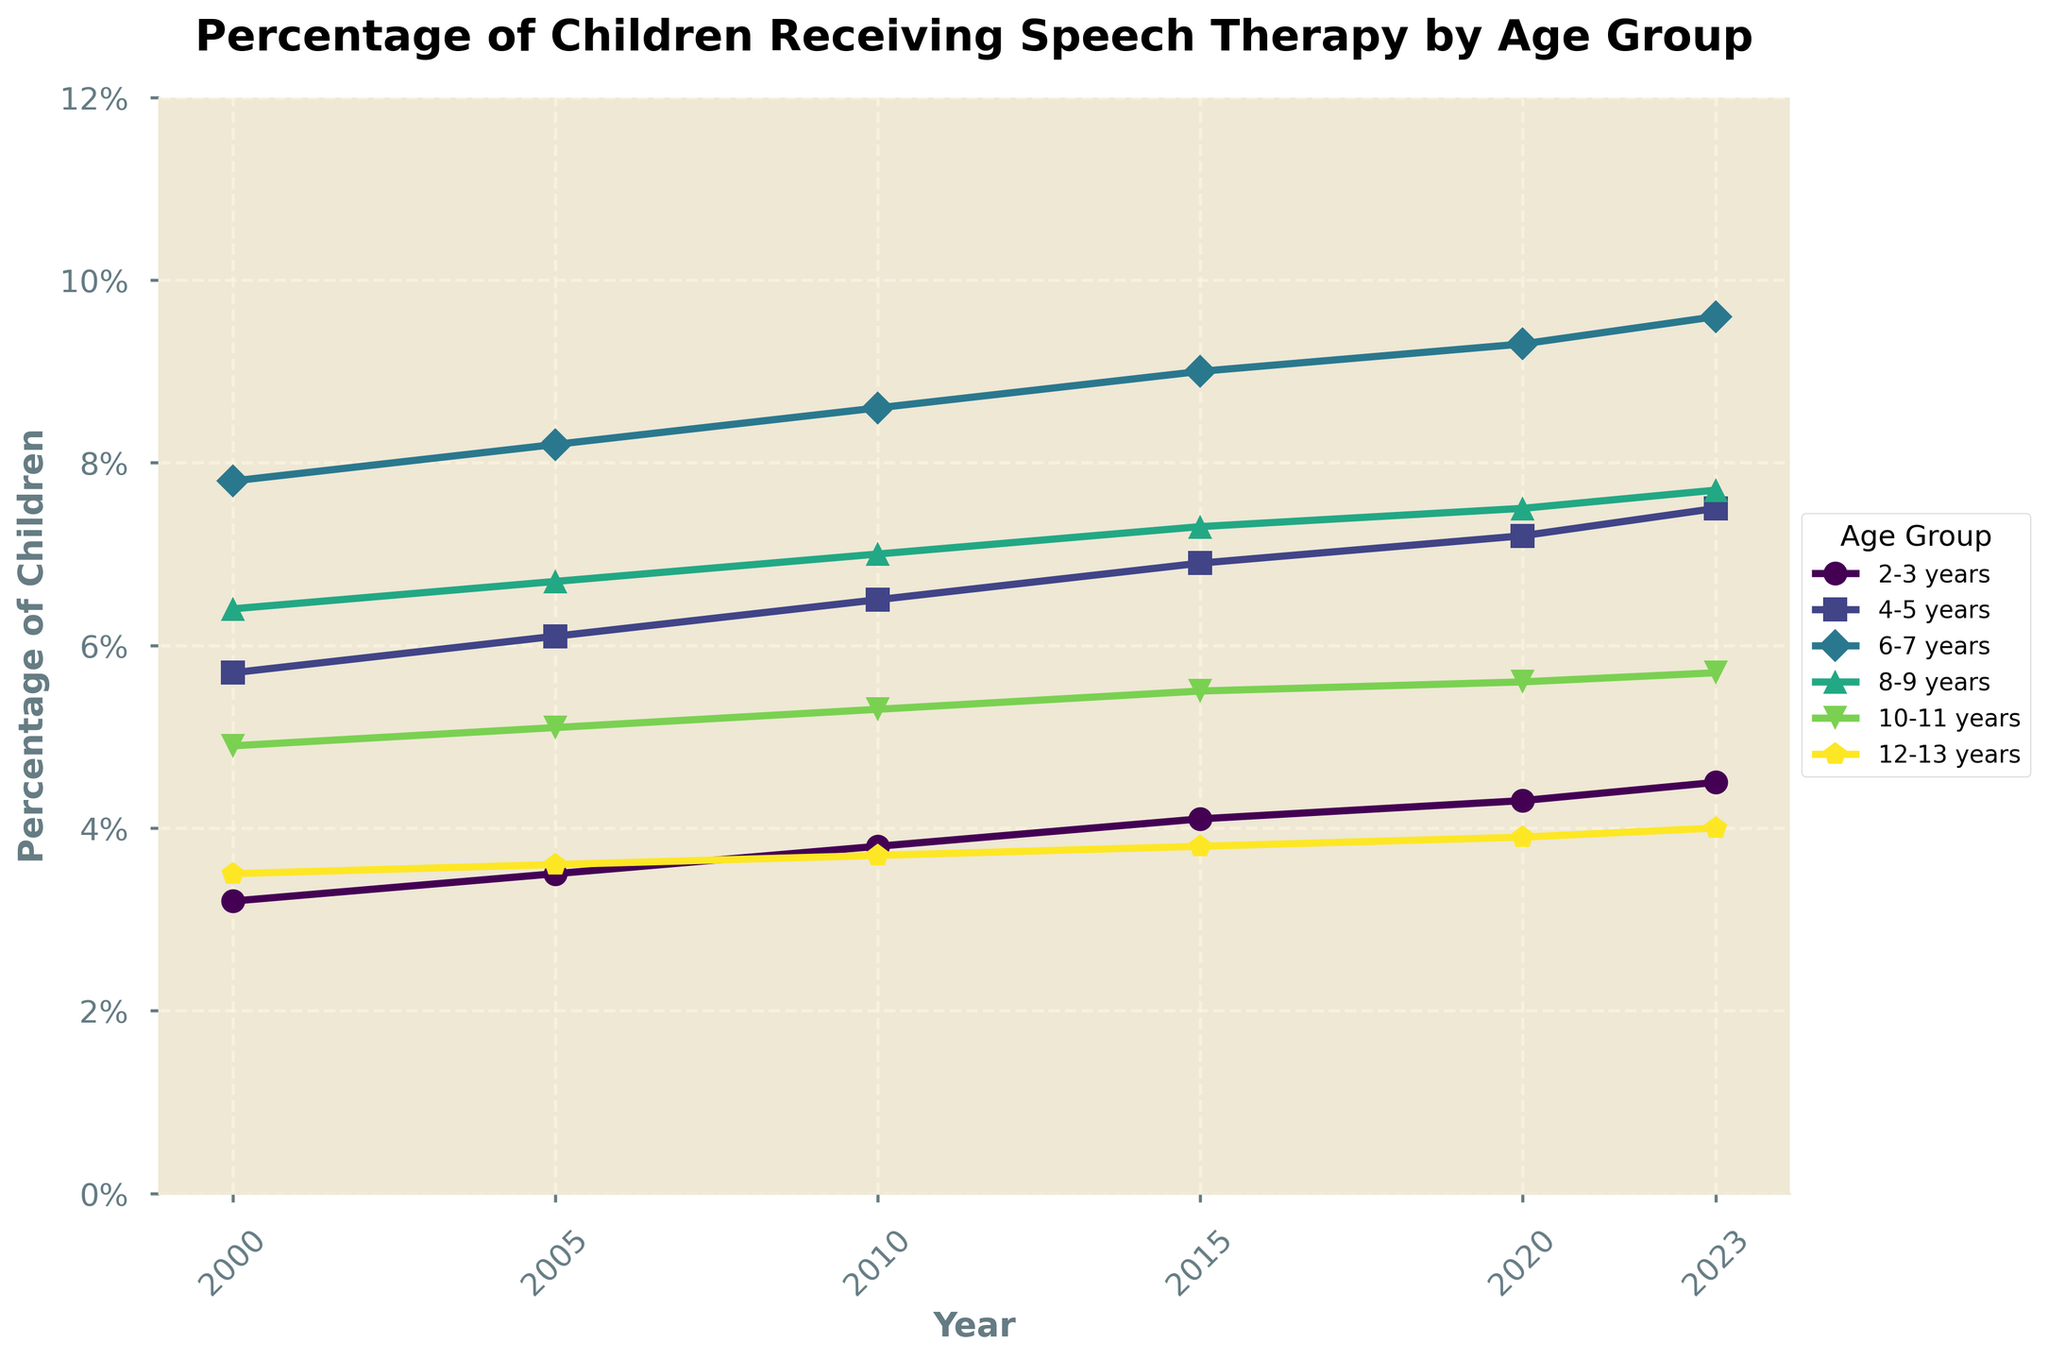What's the trend in the percentage of children receiving speech therapy for the 2-3 years age group from 2000 to 2023? The line for the 2-3 years age group shows a steady increase from 3.2% in 2000 to 4.5% in 2023.
Answer: A steady increase Which age group received the highest percentage of speech therapy in 2023? In 2023, the 6-7 years age group has the highest percentage of 9.6% as indicated by the peak in the lines on the rightmost side of the chart.
Answer: 6-7 years How did the percentage of speech therapy for the 4-5 years age group change between 2000 and 2023? The percentage increased from 5.7% in 2000 to 7.5% in 2023. The line shows a consistent upward trend.
Answer: Increased Which age group shows the smallest change in percentage from 2000 to 2023? The line for the 12-13 years age group shows the smallest increase in percentage, going from 3.5% in 2000 to 4.0% in 2023.
Answer: 12-13 years By how much did the percentage of children receiving speech therapy in the 6-7 years age group grow between 2000 and 2023? The percentage grew from 7.8% in 2000 to 9.6% in 2023. The difference is 9.6% - 7.8% = 1.8%.
Answer: 1.8% Which age groups saw an increase in speech therapy percentage every recorded year (2005, 2010, 2015, 2020, 2023)? The age groups 2-3 years, 4-5 years, and 6-7 years showed a consistent increase in each recorded year, evident from their continuously rising lines.
Answer: 2-3 years, 4-5 years, 6-7 years In 2010, which age groups had percentages that were closest to each other, and what were those percentages? In 2010, the 2-3 years age group had 3.8%, and the 12-13 years age group had 3.7%, making them the closest in percentage.
Answer: 2-3 years (3.8%) and 12-13 years (3.7%) What is the average percentage of children receiving speech therapy for the 10-11 years age group over the recorded years? Sum the percentages for 10-11 years (4.9+5.1+5.3+5.5+5.6+5.7) = 32.1. Then divide by 6: 32.1/6 = 5.35%.
Answer: 5.35% How do the trends from 2000 to 2023 compare between the 4-5 years and 8-9 years age groups? Both groups show an increasing trend. However, the 4-5 years group increases from 5.7% to 7.5%, and the 8-9 years group increases from 6.4% to 7.7%, showing that both have grown but the 4-5 years group starts lower and catches up.
Answer: Both show an increase, with 4-5 years starting lower and catching up In 2020, which age group's line is the second highest, and what is its percentage? In 2020, the second highest line is for the 4-5 years age group with a percentage of 7.2%.
Answer: 4-5 years, 7.2% 